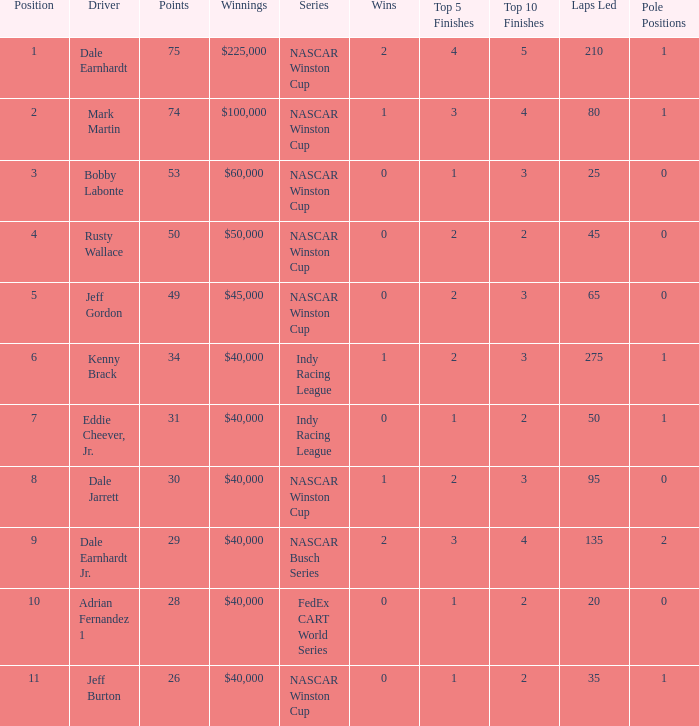How much did Kenny Brack win? $40,000. 